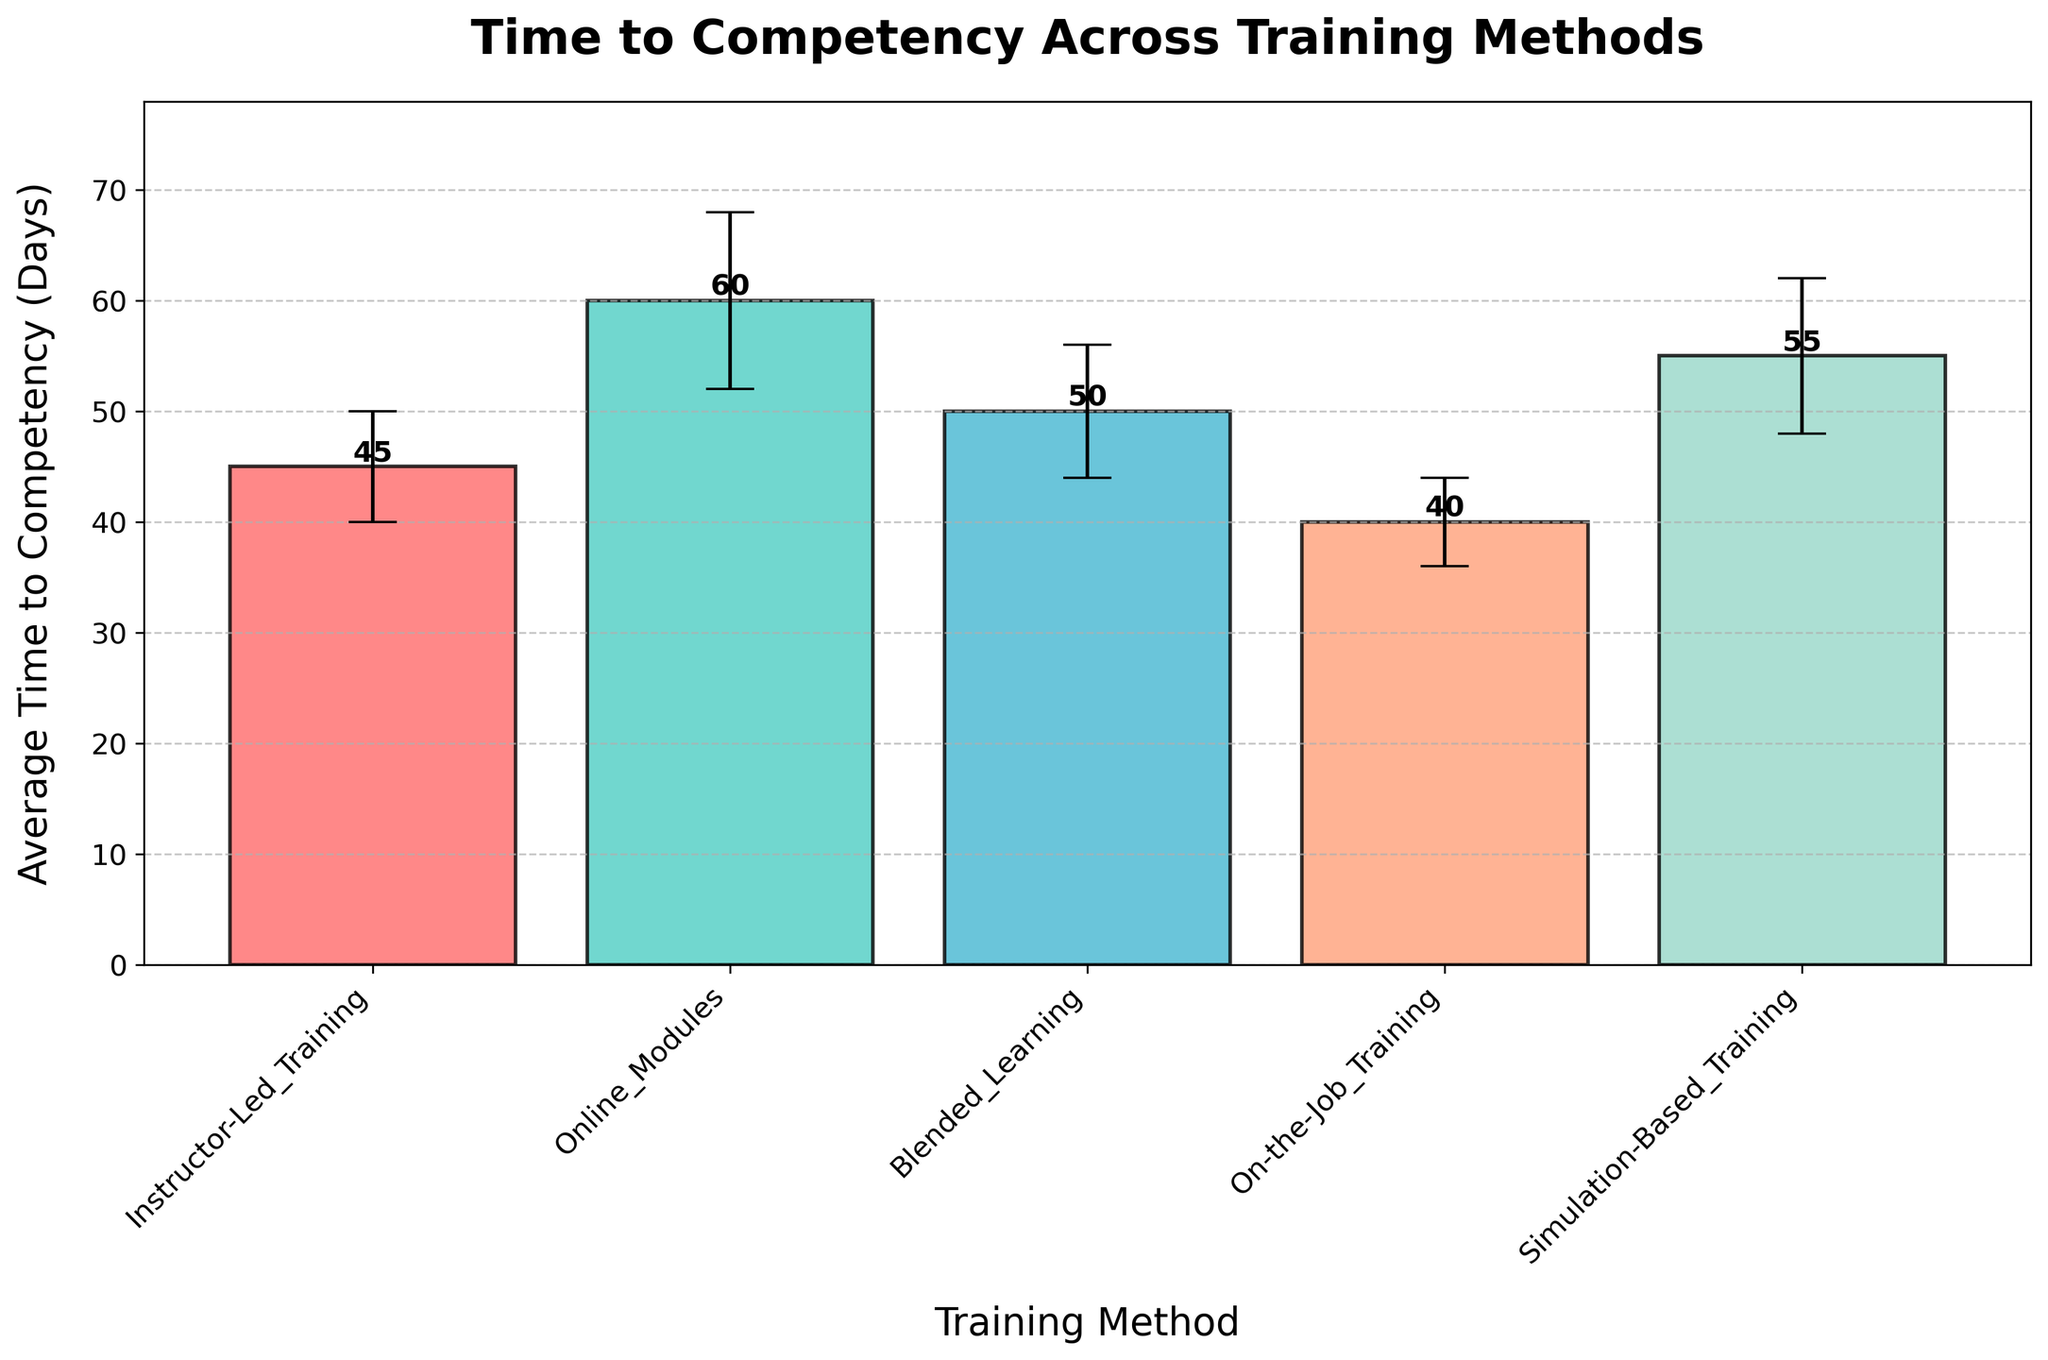What is the training method with the shortest average time to competency? The bar representing 'On-the-Job Training' has the lowest height, indicating it requires the least number of days.
Answer: On-the-Job Training What are the error margins in days for 'Blended Learning' and 'Simulation-Based Training'? The error bars for 'Blended Learning' and 'Simulation-Based Training' extend 6 and 7 days from the average times, respectively.
Answer: 6 days and 7 days Which two training methods have the closest average times to competency and what are those times? 'Instructor-Led Training' and 'Simulation-Based Training' are closest with 45 days and 55 days, respectively. The difference between them is just 5 days (half plus full error margin) when averaging their errors.
Answer: Instructor-Led Training and Simulation-Based Training, 45 days and 55 days How much longer does 'Online Modules' take on average compared to 'On-the-Job Training'? 'Online Modules' takes 60 days while 'On-the-Job Training' takes 40 days. The difference is 60 - 40 = 20 days.
Answer: 20 days What is the overall average time to competency for all training methods shown in the figure? (45 + 60 + 50 + 40 + 55) / 5 = 250 / 5 = 50 days.
Answer: 50 days Which training method has the largest error margin and what is it? 'Online Modules' has the largest error margin at 8 days.
Answer: Online Modules, 8 days By how many days does the error margin for 'Instructor-Led Training' differ from 'On-the-Job Training'? The 'Instructor-Led Training' has an error margin of 5 days, and 'On-the-Job Training' has 4 days. The difference is 5 - 4 = 1 day.
Answer: 1 day What is the title of the figure and the axis labels? The title is 'Time to Competency Across Training Methods', the x-axis label is 'Training Method', and the y-axis label is 'Average Time to Competency (Days)'
Answer: Time to Competency Across Training Methods, Training Method, Average Time to Competency (Days) Which training method has the highest average time to competency, and how many days is it? 'Online Modules' has the highest average time to competency at 60 days.
Answer: Online Modules, 60 days 